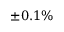<formula> <loc_0><loc_0><loc_500><loc_500>\pm 0 . 1 \%</formula> 